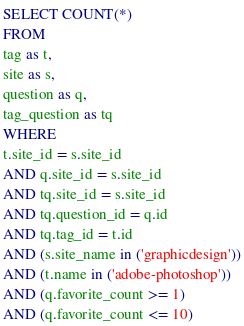<code> <loc_0><loc_0><loc_500><loc_500><_SQL_>SELECT COUNT(*)
FROM
tag as t,
site as s,
question as q,
tag_question as tq
WHERE
t.site_id = s.site_id
AND q.site_id = s.site_id
AND tq.site_id = s.site_id
AND tq.question_id = q.id
AND tq.tag_id = t.id
AND (s.site_name in ('graphicdesign'))
AND (t.name in ('adobe-photoshop'))
AND (q.favorite_count >= 1)
AND (q.favorite_count <= 10)
</code> 